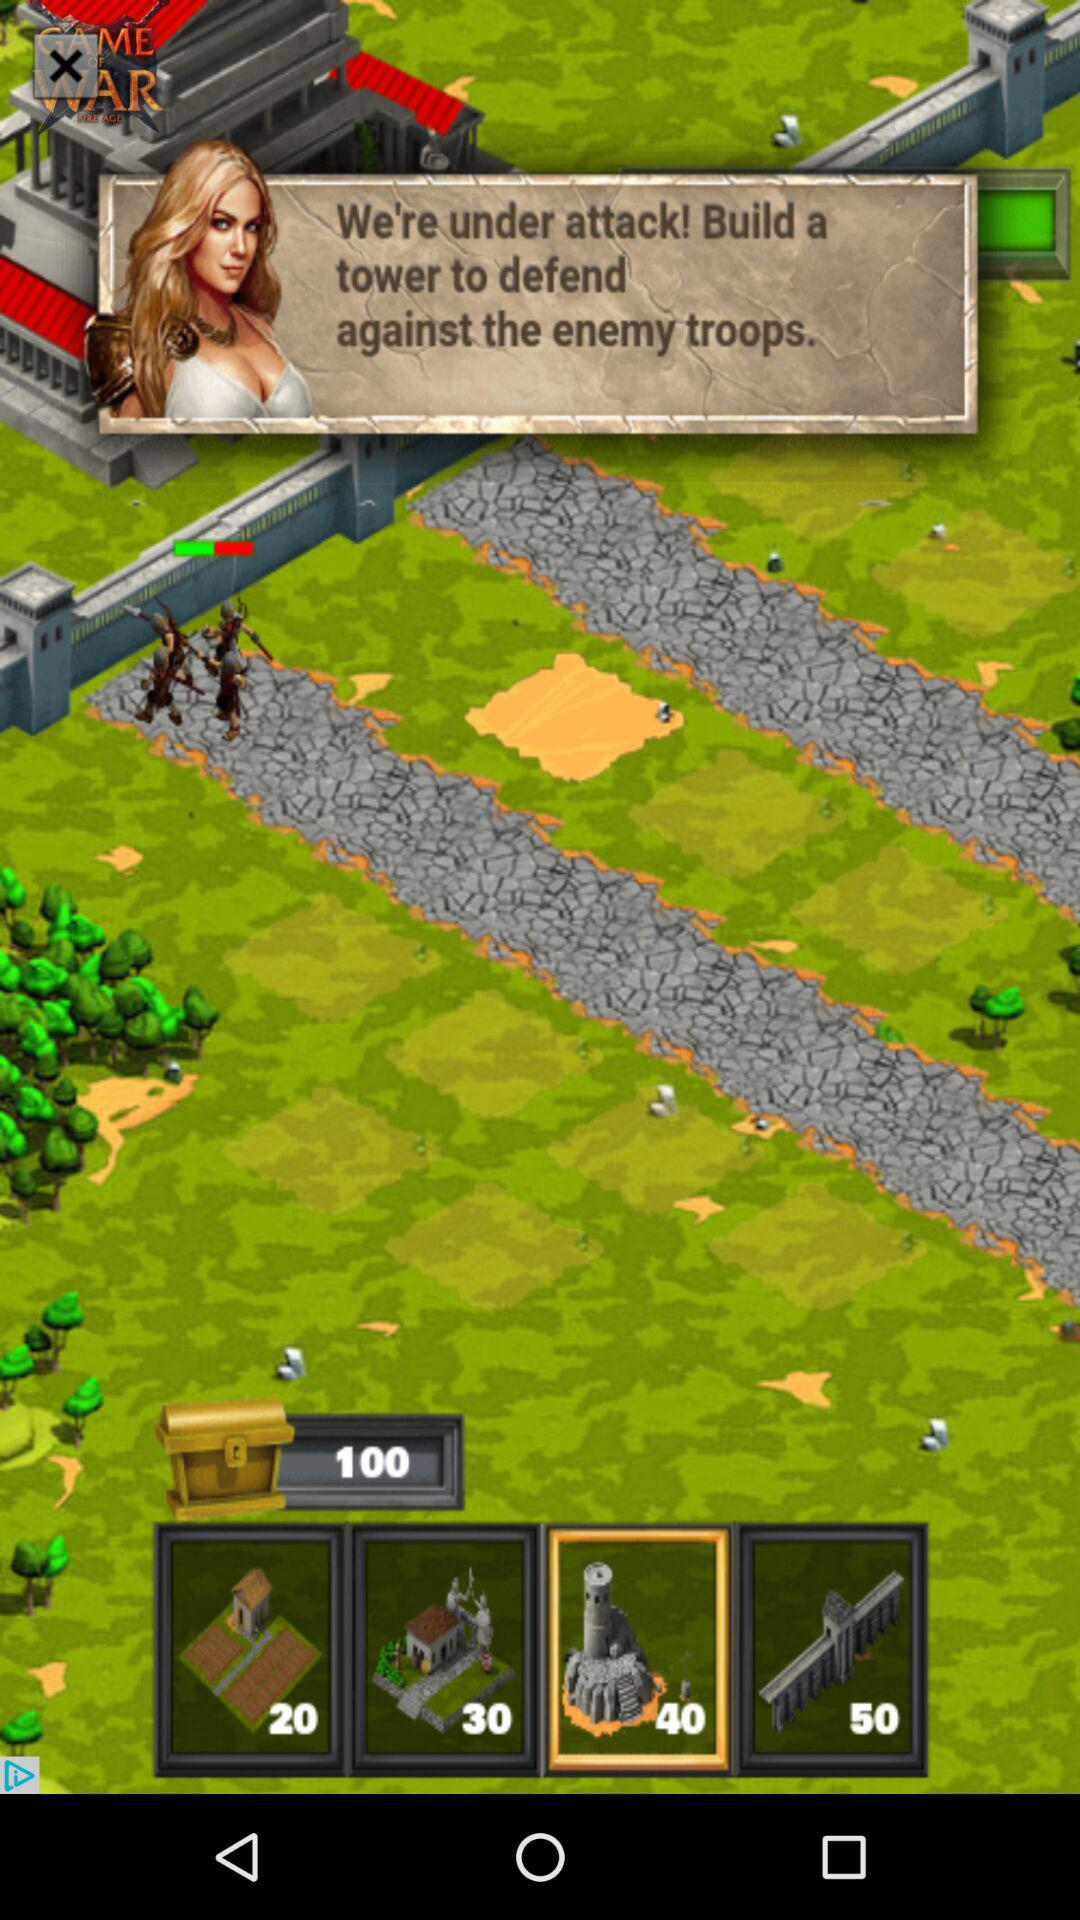How long does it take to build a tower?
When the provided information is insufficient, respond with <no answer>. <no answer> 